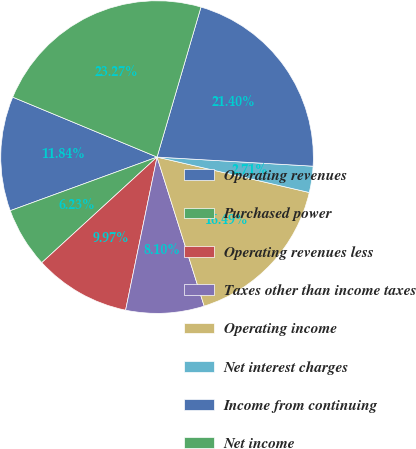Convert chart. <chart><loc_0><loc_0><loc_500><loc_500><pie_chart><fcel>Operating revenues<fcel>Purchased power<fcel>Operating revenues less<fcel>Taxes other than income taxes<fcel>Operating income<fcel>Net interest charges<fcel>Income from continuing<fcel>Net income<nl><fcel>11.84%<fcel>6.23%<fcel>9.97%<fcel>8.1%<fcel>16.49%<fcel>2.71%<fcel>21.4%<fcel>23.27%<nl></chart> 